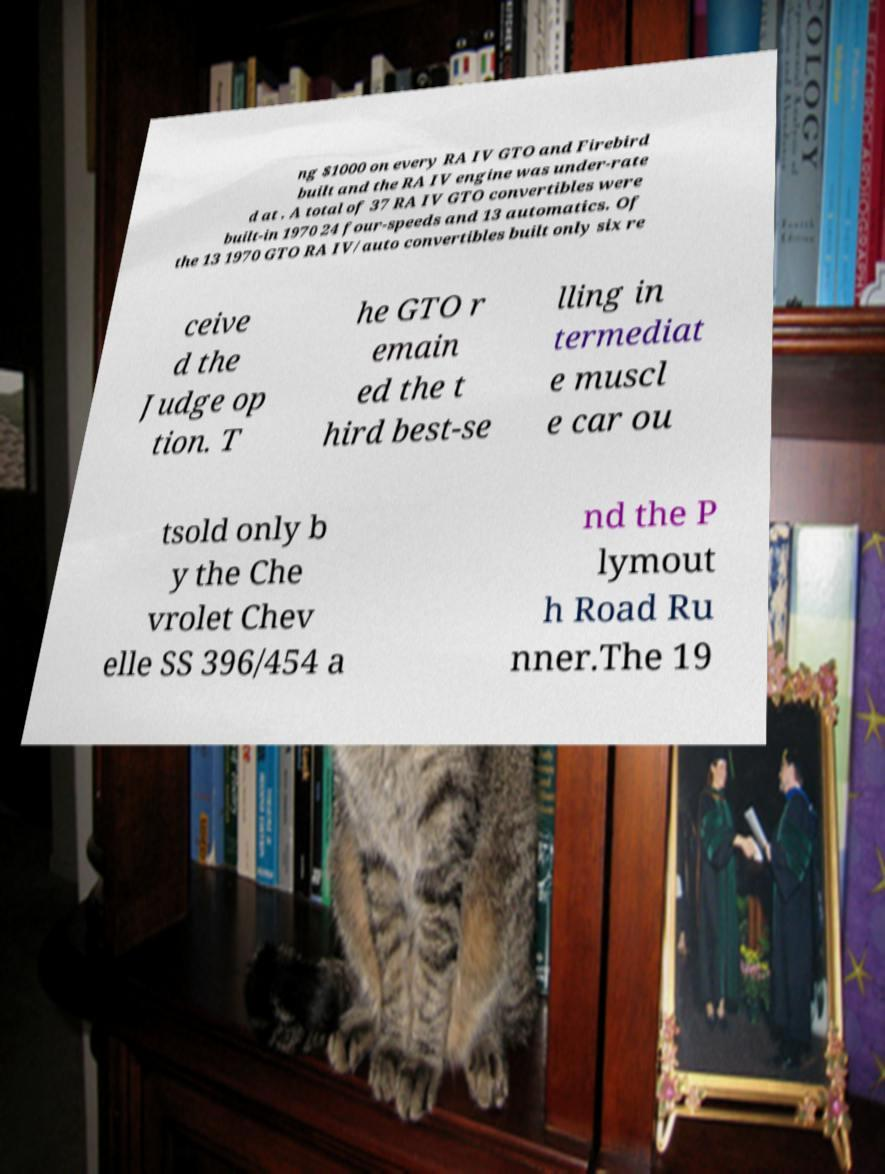What messages or text are displayed in this image? I need them in a readable, typed format. ng $1000 on every RA IV GTO and Firebird built and the RA IV engine was under-rate d at . A total of 37 RA IV GTO convertibles were built-in 1970 24 four-speeds and 13 automatics. Of the 13 1970 GTO RA IV/auto convertibles built only six re ceive d the Judge op tion. T he GTO r emain ed the t hird best-se lling in termediat e muscl e car ou tsold only b y the Che vrolet Chev elle SS 396/454 a nd the P lymout h Road Ru nner.The 19 